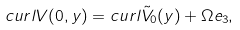<formula> <loc_0><loc_0><loc_500><loc_500>c u r l V ( 0 , y ) = c u r l \tilde { V } _ { 0 } ( y ) + \Omega e _ { 3 } ,</formula> 